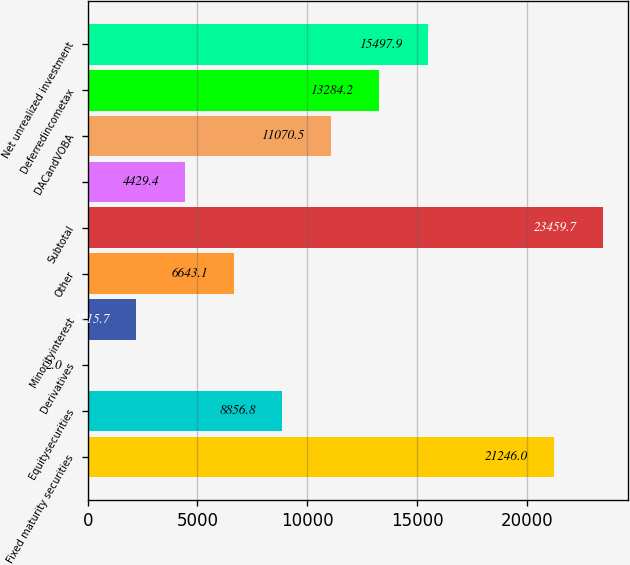Convert chart to OTSL. <chart><loc_0><loc_0><loc_500><loc_500><bar_chart><fcel>Fixed maturity securities<fcel>Equitysecurities<fcel>Derivatives<fcel>Minorityinterest<fcel>Other<fcel>Subtotal<fcel>Unnamed: 6<fcel>DACandVOBA<fcel>Deferredincometax<fcel>Net unrealized investment<nl><fcel>21246<fcel>8856.8<fcel>2<fcel>2215.7<fcel>6643.1<fcel>23459.7<fcel>4429.4<fcel>11070.5<fcel>13284.2<fcel>15497.9<nl></chart> 